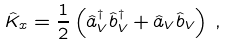Convert formula to latex. <formula><loc_0><loc_0><loc_500><loc_500>\hat { K } _ { x } = \frac { 1 } { 2 } \left ( \hat { a } _ { V } ^ { \dagger } \hat { b } _ { V } ^ { \dagger } + \hat { a } _ { V } \hat { b } _ { V } \right ) \, ,</formula> 